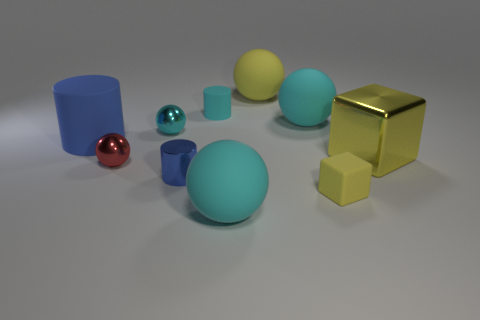Subtract all cyan spheres. How many were subtracted if there are1cyan spheres left? 2 Subtract all gray cylinders. How many cyan balls are left? 3 Subtract 1 spheres. How many spheres are left? 4 Subtract all red metal balls. How many balls are left? 4 Subtract all yellow spheres. How many spheres are left? 4 Subtract all blue spheres. Subtract all gray blocks. How many spheres are left? 5 Subtract all blocks. How many objects are left? 8 Subtract 0 yellow cylinders. How many objects are left? 10 Subtract all blue matte blocks. Subtract all big rubber objects. How many objects are left? 6 Add 7 metal cylinders. How many metal cylinders are left? 8 